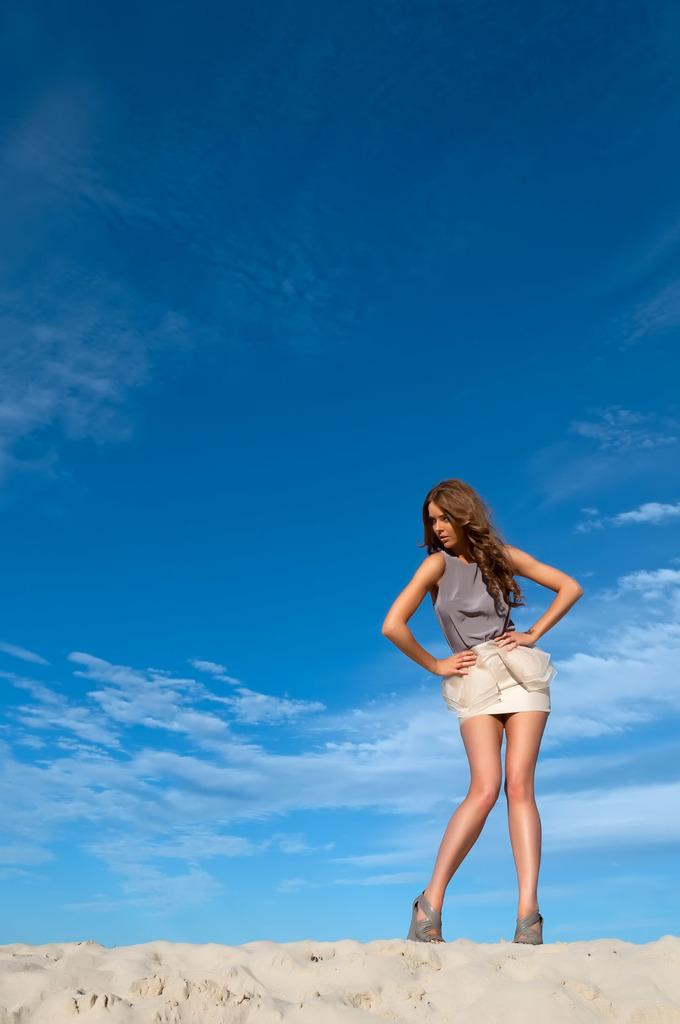Who is the main subject in the image? There is a woman in the image. Can you describe the woman's appearance? The woman has long hair and is wearing a dress. What is the woman's position in the image? The woman is standing on the ground. What can be seen in the background of the image? The sky is visible in the background of the image. How would you describe the sky in the image? The sky appears to be cloudy. How many lizards are crawling on the woman's dress in the image? There are no lizards present in the image; the woman is wearing a dress, but no lizards are visible. What type of card is the woman holding in the image? There is no card present in the image; the woman is not holding any object, including a card. 